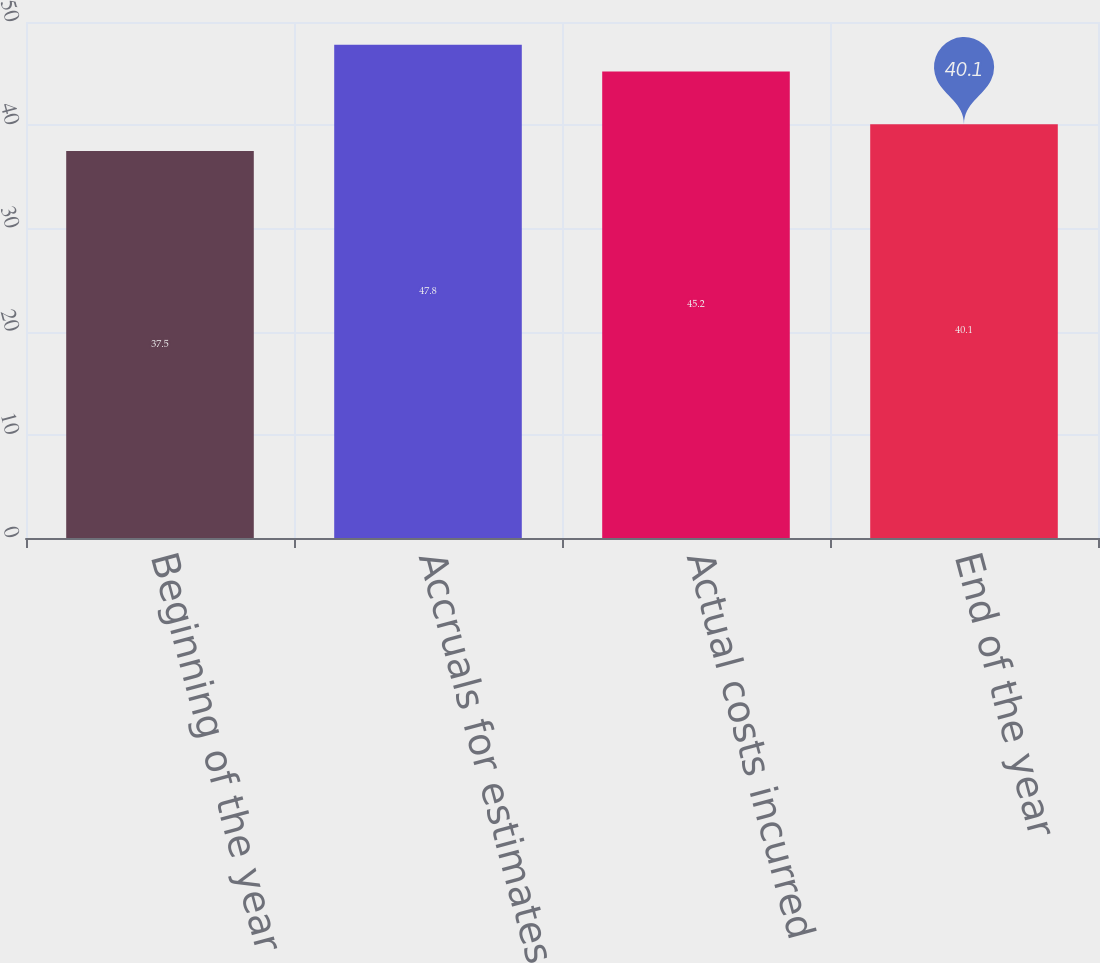Convert chart. <chart><loc_0><loc_0><loc_500><loc_500><bar_chart><fcel>Beginning of the year<fcel>Accruals for estimates<fcel>Actual costs incurred<fcel>End of the year<nl><fcel>37.5<fcel>47.8<fcel>45.2<fcel>40.1<nl></chart> 